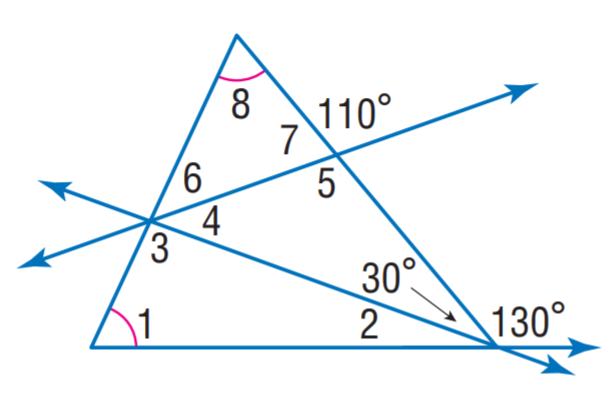Answer the mathemtical geometry problem and directly provide the correct option letter.
Question: Find m \angle 5.
Choices: A: 95 B: 100 C: 110 D: 115 C 